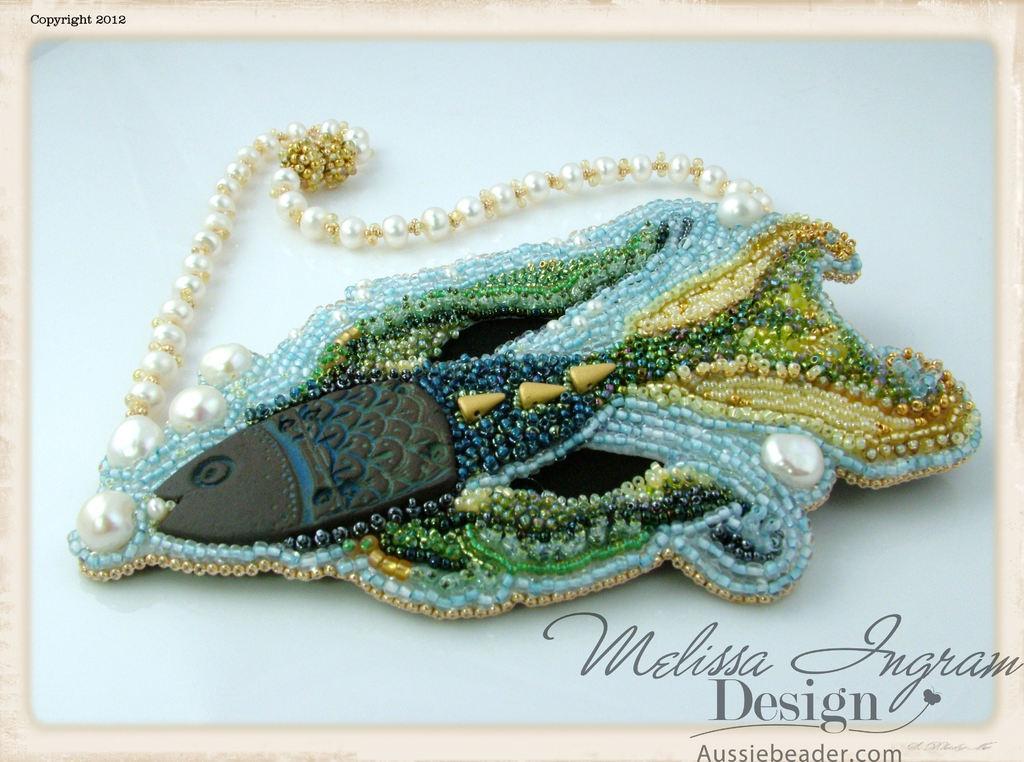In one or two sentences, can you explain what this image depicts? In this image I can see an object to which I can see number of beads which are blue, gold, cream and black in color are attached and I can see few pearls which are white in color to the object. I can see the object is on a blue colored surface. 